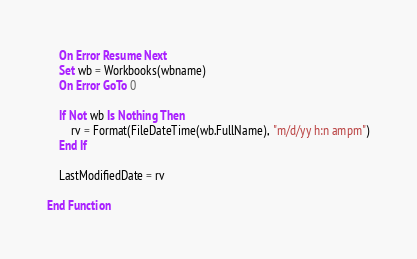<code> <loc_0><loc_0><loc_500><loc_500><_VisualBasic_>    On Error Resume Next
    Set wb = Workbooks(wbname)
    On Error GoTo 0

    If Not wb Is Nothing Then
        rv = Format(FileDateTime(wb.FullName), "m/d/yy h:n ampm")
    End If

    LastModifiedDate = rv

End Function</code> 